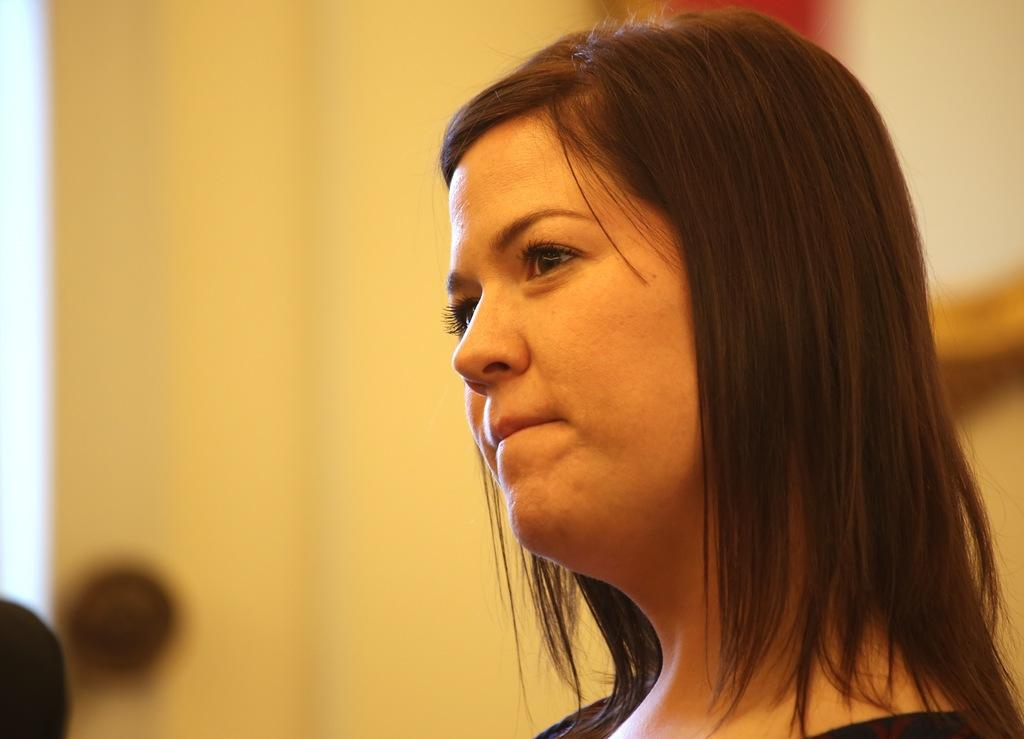Who is the main subject in the image? There is a woman in the image. What can be observed about the background of the image? The background of the image is blurred. What type of object is present in the background of the image? There is a frame in the background of the image. What else can be seen in the background of the image? There is a wall in the background of the image. What type of argument is the woman having with the caption in the image? There is no argument or caption present in the image; it only features a woman and a blurred background with a frame and a wall. 